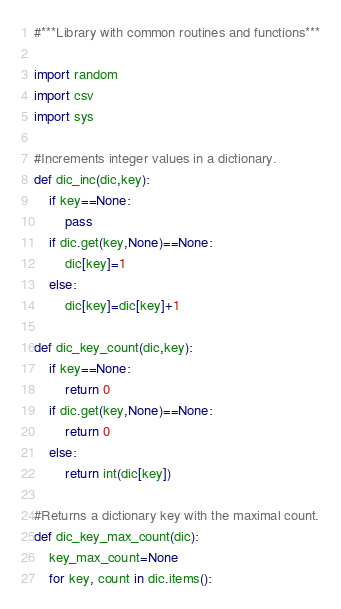<code> <loc_0><loc_0><loc_500><loc_500><_Python_>#***Library with common routines and functions***

import random
import csv
import sys

#Increments integer values in a dictionary.
def dic_inc(dic,key):
	if key==None:
		pass
	if dic.get(key,None)==None:
		dic[key]=1
	else:
		dic[key]=dic[key]+1

def dic_key_count(dic,key):
	if key==None:
		return 0
	if dic.get(key,None)==None:
		return 0
	else:
		return int(dic[key])

#Returns a dictionary key with the maximal count.
def dic_key_max_count(dic):
	key_max_count=None
	for key, count in dic.items():</code> 